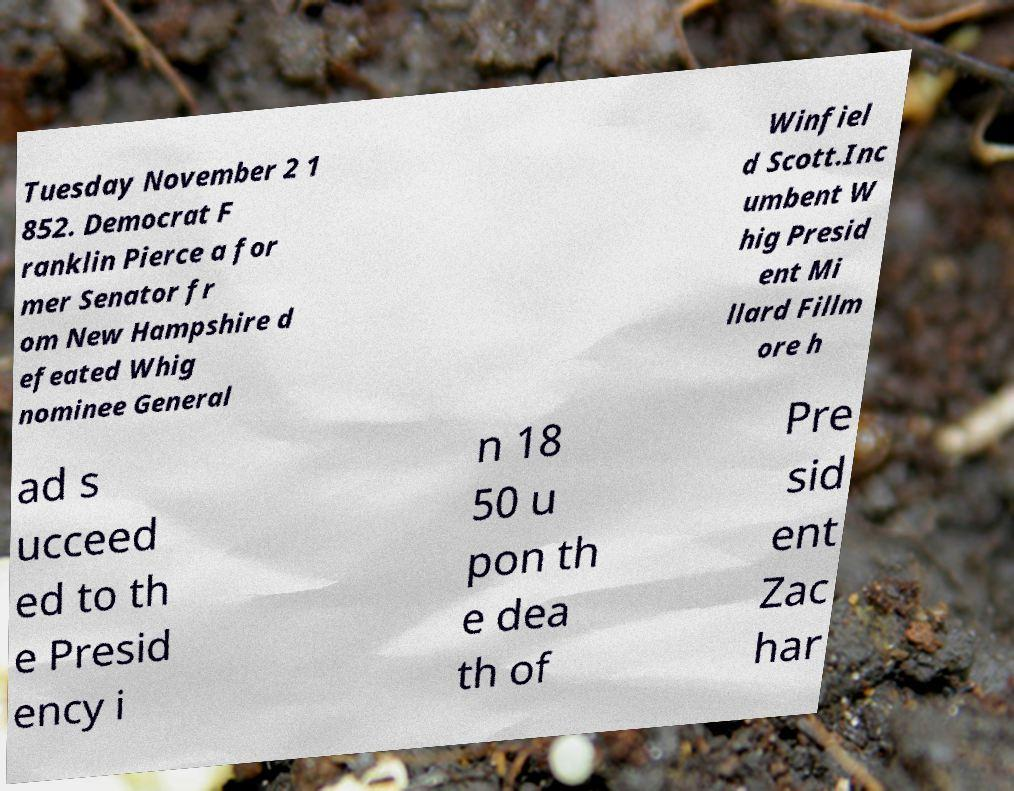There's text embedded in this image that I need extracted. Can you transcribe it verbatim? Tuesday November 2 1 852. Democrat F ranklin Pierce a for mer Senator fr om New Hampshire d efeated Whig nominee General Winfiel d Scott.Inc umbent W hig Presid ent Mi llard Fillm ore h ad s ucceed ed to th e Presid ency i n 18 50 u pon th e dea th of Pre sid ent Zac har 